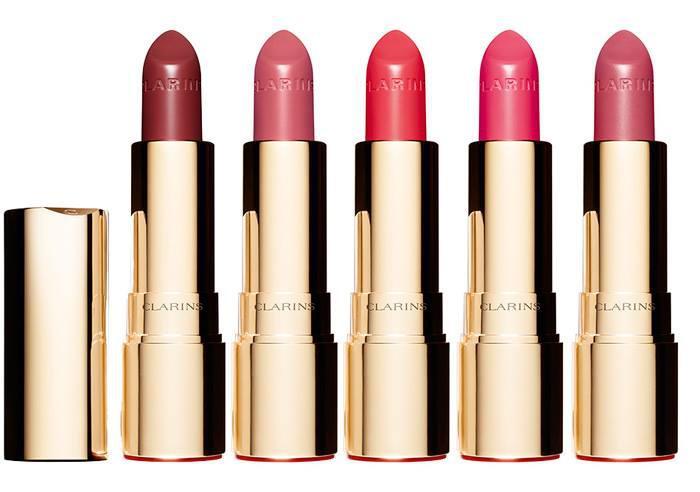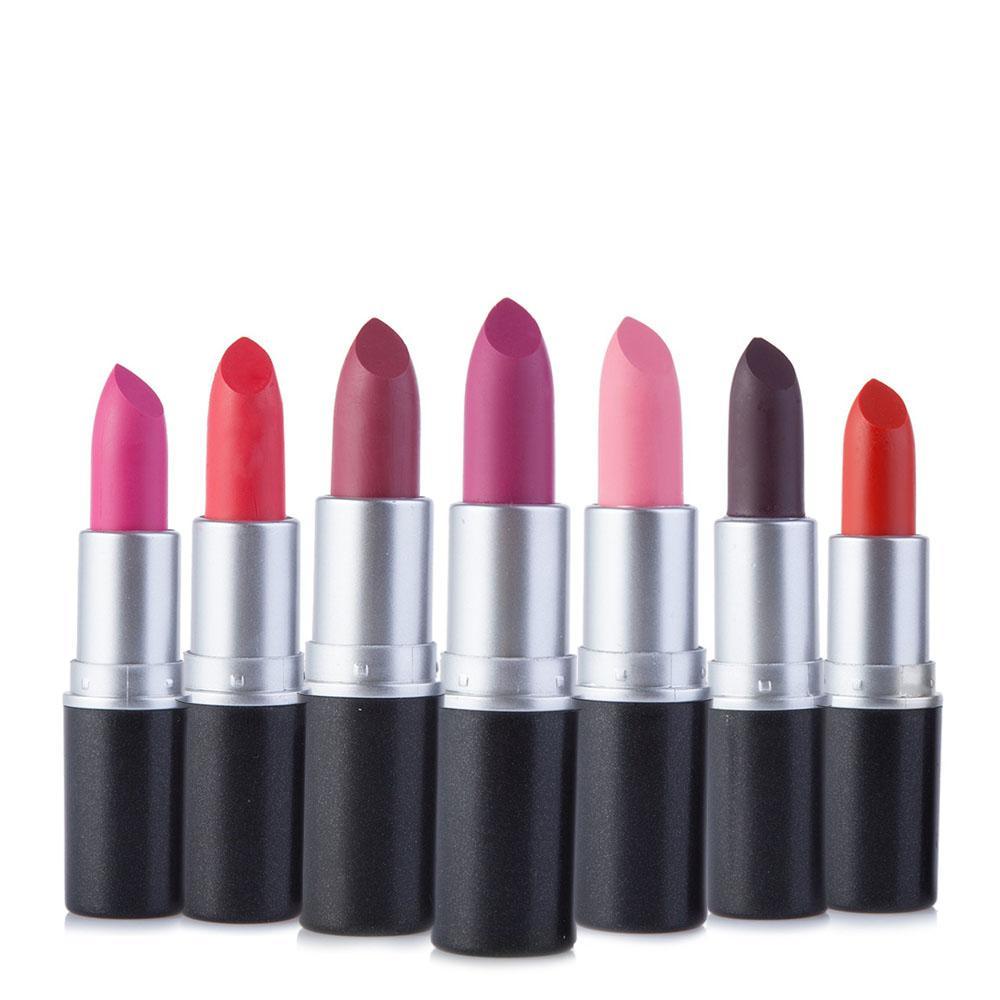The first image is the image on the left, the second image is the image on the right. Evaluate the accuracy of this statement regarding the images: "One image shows exactly five available shades of lipstick.". Is it true? Answer yes or no. Yes. The first image is the image on the left, the second image is the image on the right. Assess this claim about the two images: "There are at least six lipsticks in the image on the right.". Correct or not? Answer yes or no. Yes. The first image is the image on the left, the second image is the image on the right. Given the left and right images, does the statement "There are more lipsticks on the right than on the left image." hold true? Answer yes or no. Yes. 